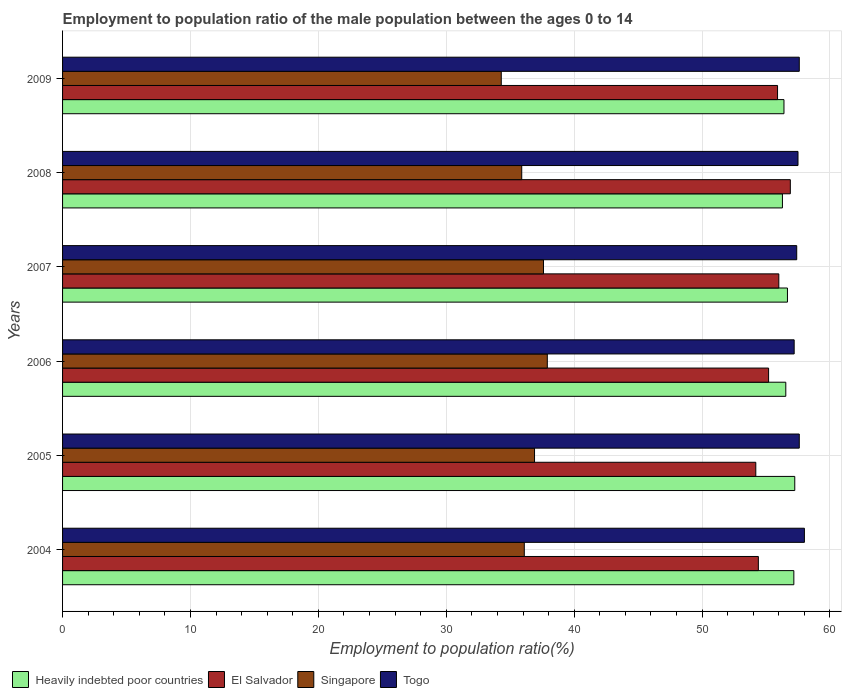How many different coloured bars are there?
Offer a terse response. 4. How many groups of bars are there?
Ensure brevity in your answer.  6. Are the number of bars per tick equal to the number of legend labels?
Ensure brevity in your answer.  Yes. How many bars are there on the 5th tick from the top?
Give a very brief answer. 4. What is the label of the 4th group of bars from the top?
Provide a short and direct response. 2006. In how many cases, is the number of bars for a given year not equal to the number of legend labels?
Provide a succinct answer. 0. What is the employment to population ratio in Heavily indebted poor countries in 2004?
Offer a very short reply. 57.17. Across all years, what is the maximum employment to population ratio in Singapore?
Ensure brevity in your answer.  37.9. Across all years, what is the minimum employment to population ratio in Togo?
Make the answer very short. 57.2. In which year was the employment to population ratio in Heavily indebted poor countries minimum?
Make the answer very short. 2008. What is the total employment to population ratio in Singapore in the graph?
Your answer should be compact. 218.7. What is the difference between the employment to population ratio in Singapore in 2005 and that in 2006?
Keep it short and to the point. -1. What is the difference between the employment to population ratio in Singapore in 2004 and the employment to population ratio in Heavily indebted poor countries in 2005?
Your response must be concise. -21.15. What is the average employment to population ratio in Singapore per year?
Your response must be concise. 36.45. In the year 2006, what is the difference between the employment to population ratio in Singapore and employment to population ratio in El Salvador?
Your answer should be compact. -17.3. In how many years, is the employment to population ratio in Heavily indebted poor countries greater than 56 %?
Give a very brief answer. 6. What is the ratio of the employment to population ratio in El Salvador in 2004 to that in 2007?
Provide a succinct answer. 0.97. Is the employment to population ratio in Singapore in 2005 less than that in 2007?
Offer a terse response. Yes. Is the difference between the employment to population ratio in Singapore in 2004 and 2005 greater than the difference between the employment to population ratio in El Salvador in 2004 and 2005?
Your response must be concise. No. What is the difference between the highest and the second highest employment to population ratio in El Salvador?
Offer a very short reply. 0.9. What is the difference between the highest and the lowest employment to population ratio in Heavily indebted poor countries?
Make the answer very short. 0.96. In how many years, is the employment to population ratio in Heavily indebted poor countries greater than the average employment to population ratio in Heavily indebted poor countries taken over all years?
Provide a short and direct response. 2. Is the sum of the employment to population ratio in Singapore in 2004 and 2007 greater than the maximum employment to population ratio in Heavily indebted poor countries across all years?
Your answer should be very brief. Yes. Is it the case that in every year, the sum of the employment to population ratio in El Salvador and employment to population ratio in Heavily indebted poor countries is greater than the sum of employment to population ratio in Singapore and employment to population ratio in Togo?
Ensure brevity in your answer.  Yes. What does the 2nd bar from the top in 2008 represents?
Ensure brevity in your answer.  Singapore. What does the 4th bar from the bottom in 2005 represents?
Provide a succinct answer. Togo. Is it the case that in every year, the sum of the employment to population ratio in Heavily indebted poor countries and employment to population ratio in Singapore is greater than the employment to population ratio in Togo?
Give a very brief answer. Yes. Are all the bars in the graph horizontal?
Ensure brevity in your answer.  Yes. Are the values on the major ticks of X-axis written in scientific E-notation?
Keep it short and to the point. No. Does the graph contain any zero values?
Make the answer very short. No. How are the legend labels stacked?
Your answer should be compact. Horizontal. What is the title of the graph?
Your answer should be very brief. Employment to population ratio of the male population between the ages 0 to 14. What is the label or title of the X-axis?
Ensure brevity in your answer.  Employment to population ratio(%). What is the Employment to population ratio(%) in Heavily indebted poor countries in 2004?
Keep it short and to the point. 57.17. What is the Employment to population ratio(%) of El Salvador in 2004?
Your answer should be very brief. 54.4. What is the Employment to population ratio(%) of Singapore in 2004?
Provide a short and direct response. 36.1. What is the Employment to population ratio(%) of Togo in 2004?
Offer a very short reply. 58. What is the Employment to population ratio(%) of Heavily indebted poor countries in 2005?
Provide a succinct answer. 57.25. What is the Employment to population ratio(%) of El Salvador in 2005?
Your answer should be very brief. 54.2. What is the Employment to population ratio(%) in Singapore in 2005?
Make the answer very short. 36.9. What is the Employment to population ratio(%) of Togo in 2005?
Keep it short and to the point. 57.6. What is the Employment to population ratio(%) of Heavily indebted poor countries in 2006?
Keep it short and to the point. 56.55. What is the Employment to population ratio(%) in El Salvador in 2006?
Make the answer very short. 55.2. What is the Employment to population ratio(%) of Singapore in 2006?
Give a very brief answer. 37.9. What is the Employment to population ratio(%) in Togo in 2006?
Keep it short and to the point. 57.2. What is the Employment to population ratio(%) of Heavily indebted poor countries in 2007?
Your response must be concise. 56.68. What is the Employment to population ratio(%) in Singapore in 2007?
Give a very brief answer. 37.6. What is the Employment to population ratio(%) in Togo in 2007?
Offer a terse response. 57.4. What is the Employment to population ratio(%) of Heavily indebted poor countries in 2008?
Your response must be concise. 56.28. What is the Employment to population ratio(%) in El Salvador in 2008?
Give a very brief answer. 56.9. What is the Employment to population ratio(%) in Singapore in 2008?
Offer a very short reply. 35.9. What is the Employment to population ratio(%) of Togo in 2008?
Ensure brevity in your answer.  57.5. What is the Employment to population ratio(%) in Heavily indebted poor countries in 2009?
Provide a short and direct response. 56.4. What is the Employment to population ratio(%) in El Salvador in 2009?
Offer a very short reply. 55.9. What is the Employment to population ratio(%) in Singapore in 2009?
Provide a succinct answer. 34.3. What is the Employment to population ratio(%) in Togo in 2009?
Provide a short and direct response. 57.6. Across all years, what is the maximum Employment to population ratio(%) in Heavily indebted poor countries?
Provide a succinct answer. 57.25. Across all years, what is the maximum Employment to population ratio(%) of El Salvador?
Provide a short and direct response. 56.9. Across all years, what is the maximum Employment to population ratio(%) in Singapore?
Give a very brief answer. 37.9. Across all years, what is the maximum Employment to population ratio(%) of Togo?
Give a very brief answer. 58. Across all years, what is the minimum Employment to population ratio(%) of Heavily indebted poor countries?
Ensure brevity in your answer.  56.28. Across all years, what is the minimum Employment to population ratio(%) of El Salvador?
Ensure brevity in your answer.  54.2. Across all years, what is the minimum Employment to population ratio(%) of Singapore?
Keep it short and to the point. 34.3. Across all years, what is the minimum Employment to population ratio(%) of Togo?
Your answer should be very brief. 57.2. What is the total Employment to population ratio(%) in Heavily indebted poor countries in the graph?
Make the answer very short. 340.33. What is the total Employment to population ratio(%) in El Salvador in the graph?
Offer a very short reply. 332.6. What is the total Employment to population ratio(%) of Singapore in the graph?
Offer a terse response. 218.7. What is the total Employment to population ratio(%) in Togo in the graph?
Ensure brevity in your answer.  345.3. What is the difference between the Employment to population ratio(%) of Heavily indebted poor countries in 2004 and that in 2005?
Provide a short and direct response. -0.07. What is the difference between the Employment to population ratio(%) in El Salvador in 2004 and that in 2005?
Offer a very short reply. 0.2. What is the difference between the Employment to population ratio(%) in Singapore in 2004 and that in 2005?
Ensure brevity in your answer.  -0.8. What is the difference between the Employment to population ratio(%) in Heavily indebted poor countries in 2004 and that in 2006?
Ensure brevity in your answer.  0.63. What is the difference between the Employment to population ratio(%) in El Salvador in 2004 and that in 2006?
Give a very brief answer. -0.8. What is the difference between the Employment to population ratio(%) of Togo in 2004 and that in 2006?
Your answer should be compact. 0.8. What is the difference between the Employment to population ratio(%) of Heavily indebted poor countries in 2004 and that in 2007?
Ensure brevity in your answer.  0.5. What is the difference between the Employment to population ratio(%) in El Salvador in 2004 and that in 2007?
Give a very brief answer. -1.6. What is the difference between the Employment to population ratio(%) of Togo in 2004 and that in 2007?
Keep it short and to the point. 0.6. What is the difference between the Employment to population ratio(%) of Heavily indebted poor countries in 2004 and that in 2008?
Provide a succinct answer. 0.89. What is the difference between the Employment to population ratio(%) of El Salvador in 2004 and that in 2008?
Your response must be concise. -2.5. What is the difference between the Employment to population ratio(%) of Singapore in 2004 and that in 2008?
Keep it short and to the point. 0.2. What is the difference between the Employment to population ratio(%) in Heavily indebted poor countries in 2004 and that in 2009?
Provide a succinct answer. 0.77. What is the difference between the Employment to population ratio(%) of El Salvador in 2004 and that in 2009?
Make the answer very short. -1.5. What is the difference between the Employment to population ratio(%) in Singapore in 2004 and that in 2009?
Offer a very short reply. 1.8. What is the difference between the Employment to population ratio(%) of Togo in 2004 and that in 2009?
Your answer should be very brief. 0.4. What is the difference between the Employment to population ratio(%) in Heavily indebted poor countries in 2005 and that in 2006?
Ensure brevity in your answer.  0.7. What is the difference between the Employment to population ratio(%) in El Salvador in 2005 and that in 2006?
Provide a short and direct response. -1. What is the difference between the Employment to population ratio(%) of Singapore in 2005 and that in 2006?
Offer a very short reply. -1. What is the difference between the Employment to population ratio(%) in Heavily indebted poor countries in 2005 and that in 2007?
Offer a very short reply. 0.57. What is the difference between the Employment to population ratio(%) in Singapore in 2005 and that in 2007?
Provide a succinct answer. -0.7. What is the difference between the Employment to population ratio(%) in Heavily indebted poor countries in 2005 and that in 2008?
Your answer should be very brief. 0.96. What is the difference between the Employment to population ratio(%) in El Salvador in 2005 and that in 2008?
Ensure brevity in your answer.  -2.7. What is the difference between the Employment to population ratio(%) in Singapore in 2005 and that in 2008?
Your response must be concise. 1. What is the difference between the Employment to population ratio(%) in Togo in 2005 and that in 2008?
Offer a very short reply. 0.1. What is the difference between the Employment to population ratio(%) of Heavily indebted poor countries in 2005 and that in 2009?
Your answer should be very brief. 0.84. What is the difference between the Employment to population ratio(%) in Togo in 2005 and that in 2009?
Your response must be concise. 0. What is the difference between the Employment to population ratio(%) in Heavily indebted poor countries in 2006 and that in 2007?
Offer a terse response. -0.13. What is the difference between the Employment to population ratio(%) in El Salvador in 2006 and that in 2007?
Ensure brevity in your answer.  -0.8. What is the difference between the Employment to population ratio(%) in Singapore in 2006 and that in 2007?
Give a very brief answer. 0.3. What is the difference between the Employment to population ratio(%) of Togo in 2006 and that in 2007?
Offer a terse response. -0.2. What is the difference between the Employment to population ratio(%) of Heavily indebted poor countries in 2006 and that in 2008?
Keep it short and to the point. 0.26. What is the difference between the Employment to population ratio(%) in El Salvador in 2006 and that in 2008?
Keep it short and to the point. -1.7. What is the difference between the Employment to population ratio(%) of Togo in 2006 and that in 2008?
Provide a short and direct response. -0.3. What is the difference between the Employment to population ratio(%) in Heavily indebted poor countries in 2006 and that in 2009?
Provide a succinct answer. 0.14. What is the difference between the Employment to population ratio(%) in Heavily indebted poor countries in 2007 and that in 2008?
Give a very brief answer. 0.39. What is the difference between the Employment to population ratio(%) of El Salvador in 2007 and that in 2008?
Provide a succinct answer. -0.9. What is the difference between the Employment to population ratio(%) of Singapore in 2007 and that in 2008?
Give a very brief answer. 1.7. What is the difference between the Employment to population ratio(%) of Heavily indebted poor countries in 2007 and that in 2009?
Your response must be concise. 0.27. What is the difference between the Employment to population ratio(%) of Togo in 2007 and that in 2009?
Your answer should be very brief. -0.2. What is the difference between the Employment to population ratio(%) of Heavily indebted poor countries in 2008 and that in 2009?
Ensure brevity in your answer.  -0.12. What is the difference between the Employment to population ratio(%) of Singapore in 2008 and that in 2009?
Your answer should be compact. 1.6. What is the difference between the Employment to population ratio(%) in Togo in 2008 and that in 2009?
Ensure brevity in your answer.  -0.1. What is the difference between the Employment to population ratio(%) in Heavily indebted poor countries in 2004 and the Employment to population ratio(%) in El Salvador in 2005?
Offer a terse response. 2.97. What is the difference between the Employment to population ratio(%) in Heavily indebted poor countries in 2004 and the Employment to population ratio(%) in Singapore in 2005?
Your answer should be compact. 20.27. What is the difference between the Employment to population ratio(%) of Heavily indebted poor countries in 2004 and the Employment to population ratio(%) of Togo in 2005?
Ensure brevity in your answer.  -0.43. What is the difference between the Employment to population ratio(%) in Singapore in 2004 and the Employment to population ratio(%) in Togo in 2005?
Your answer should be very brief. -21.5. What is the difference between the Employment to population ratio(%) in Heavily indebted poor countries in 2004 and the Employment to population ratio(%) in El Salvador in 2006?
Make the answer very short. 1.97. What is the difference between the Employment to population ratio(%) in Heavily indebted poor countries in 2004 and the Employment to population ratio(%) in Singapore in 2006?
Give a very brief answer. 19.27. What is the difference between the Employment to population ratio(%) in Heavily indebted poor countries in 2004 and the Employment to population ratio(%) in Togo in 2006?
Give a very brief answer. -0.03. What is the difference between the Employment to population ratio(%) in El Salvador in 2004 and the Employment to population ratio(%) in Singapore in 2006?
Your answer should be very brief. 16.5. What is the difference between the Employment to population ratio(%) in El Salvador in 2004 and the Employment to population ratio(%) in Togo in 2006?
Ensure brevity in your answer.  -2.8. What is the difference between the Employment to population ratio(%) of Singapore in 2004 and the Employment to population ratio(%) of Togo in 2006?
Your answer should be very brief. -21.1. What is the difference between the Employment to population ratio(%) of Heavily indebted poor countries in 2004 and the Employment to population ratio(%) of El Salvador in 2007?
Provide a short and direct response. 1.17. What is the difference between the Employment to population ratio(%) of Heavily indebted poor countries in 2004 and the Employment to population ratio(%) of Singapore in 2007?
Make the answer very short. 19.57. What is the difference between the Employment to population ratio(%) in Heavily indebted poor countries in 2004 and the Employment to population ratio(%) in Togo in 2007?
Your answer should be very brief. -0.23. What is the difference between the Employment to population ratio(%) of El Salvador in 2004 and the Employment to population ratio(%) of Togo in 2007?
Your answer should be compact. -3. What is the difference between the Employment to population ratio(%) of Singapore in 2004 and the Employment to population ratio(%) of Togo in 2007?
Offer a terse response. -21.3. What is the difference between the Employment to population ratio(%) in Heavily indebted poor countries in 2004 and the Employment to population ratio(%) in El Salvador in 2008?
Make the answer very short. 0.27. What is the difference between the Employment to population ratio(%) of Heavily indebted poor countries in 2004 and the Employment to population ratio(%) of Singapore in 2008?
Your answer should be very brief. 21.27. What is the difference between the Employment to population ratio(%) of Heavily indebted poor countries in 2004 and the Employment to population ratio(%) of Togo in 2008?
Offer a very short reply. -0.33. What is the difference between the Employment to population ratio(%) of El Salvador in 2004 and the Employment to population ratio(%) of Togo in 2008?
Give a very brief answer. -3.1. What is the difference between the Employment to population ratio(%) in Singapore in 2004 and the Employment to population ratio(%) in Togo in 2008?
Offer a very short reply. -21.4. What is the difference between the Employment to population ratio(%) of Heavily indebted poor countries in 2004 and the Employment to population ratio(%) of El Salvador in 2009?
Your answer should be compact. 1.27. What is the difference between the Employment to population ratio(%) of Heavily indebted poor countries in 2004 and the Employment to population ratio(%) of Singapore in 2009?
Provide a succinct answer. 22.87. What is the difference between the Employment to population ratio(%) of Heavily indebted poor countries in 2004 and the Employment to population ratio(%) of Togo in 2009?
Your answer should be very brief. -0.43. What is the difference between the Employment to population ratio(%) of El Salvador in 2004 and the Employment to population ratio(%) of Singapore in 2009?
Offer a terse response. 20.1. What is the difference between the Employment to population ratio(%) in El Salvador in 2004 and the Employment to population ratio(%) in Togo in 2009?
Make the answer very short. -3.2. What is the difference between the Employment to population ratio(%) of Singapore in 2004 and the Employment to population ratio(%) of Togo in 2009?
Keep it short and to the point. -21.5. What is the difference between the Employment to population ratio(%) in Heavily indebted poor countries in 2005 and the Employment to population ratio(%) in El Salvador in 2006?
Your response must be concise. 2.05. What is the difference between the Employment to population ratio(%) of Heavily indebted poor countries in 2005 and the Employment to population ratio(%) of Singapore in 2006?
Ensure brevity in your answer.  19.35. What is the difference between the Employment to population ratio(%) in Heavily indebted poor countries in 2005 and the Employment to population ratio(%) in Togo in 2006?
Your answer should be very brief. 0.05. What is the difference between the Employment to population ratio(%) in El Salvador in 2005 and the Employment to population ratio(%) in Togo in 2006?
Offer a very short reply. -3. What is the difference between the Employment to population ratio(%) in Singapore in 2005 and the Employment to population ratio(%) in Togo in 2006?
Your answer should be very brief. -20.3. What is the difference between the Employment to population ratio(%) in Heavily indebted poor countries in 2005 and the Employment to population ratio(%) in El Salvador in 2007?
Offer a very short reply. 1.25. What is the difference between the Employment to population ratio(%) of Heavily indebted poor countries in 2005 and the Employment to population ratio(%) of Singapore in 2007?
Make the answer very short. 19.65. What is the difference between the Employment to population ratio(%) of Heavily indebted poor countries in 2005 and the Employment to population ratio(%) of Togo in 2007?
Provide a succinct answer. -0.15. What is the difference between the Employment to population ratio(%) of Singapore in 2005 and the Employment to population ratio(%) of Togo in 2007?
Your answer should be very brief. -20.5. What is the difference between the Employment to population ratio(%) in Heavily indebted poor countries in 2005 and the Employment to population ratio(%) in El Salvador in 2008?
Your answer should be very brief. 0.35. What is the difference between the Employment to population ratio(%) in Heavily indebted poor countries in 2005 and the Employment to population ratio(%) in Singapore in 2008?
Make the answer very short. 21.35. What is the difference between the Employment to population ratio(%) in Heavily indebted poor countries in 2005 and the Employment to population ratio(%) in Togo in 2008?
Offer a terse response. -0.25. What is the difference between the Employment to population ratio(%) in El Salvador in 2005 and the Employment to population ratio(%) in Togo in 2008?
Provide a succinct answer. -3.3. What is the difference between the Employment to population ratio(%) of Singapore in 2005 and the Employment to population ratio(%) of Togo in 2008?
Make the answer very short. -20.6. What is the difference between the Employment to population ratio(%) of Heavily indebted poor countries in 2005 and the Employment to population ratio(%) of El Salvador in 2009?
Give a very brief answer. 1.35. What is the difference between the Employment to population ratio(%) of Heavily indebted poor countries in 2005 and the Employment to population ratio(%) of Singapore in 2009?
Keep it short and to the point. 22.95. What is the difference between the Employment to population ratio(%) of Heavily indebted poor countries in 2005 and the Employment to population ratio(%) of Togo in 2009?
Make the answer very short. -0.35. What is the difference between the Employment to population ratio(%) of El Salvador in 2005 and the Employment to population ratio(%) of Singapore in 2009?
Offer a terse response. 19.9. What is the difference between the Employment to population ratio(%) of El Salvador in 2005 and the Employment to population ratio(%) of Togo in 2009?
Make the answer very short. -3.4. What is the difference between the Employment to population ratio(%) in Singapore in 2005 and the Employment to population ratio(%) in Togo in 2009?
Give a very brief answer. -20.7. What is the difference between the Employment to population ratio(%) in Heavily indebted poor countries in 2006 and the Employment to population ratio(%) in El Salvador in 2007?
Ensure brevity in your answer.  0.55. What is the difference between the Employment to population ratio(%) in Heavily indebted poor countries in 2006 and the Employment to population ratio(%) in Singapore in 2007?
Provide a short and direct response. 18.95. What is the difference between the Employment to population ratio(%) of Heavily indebted poor countries in 2006 and the Employment to population ratio(%) of Togo in 2007?
Your answer should be compact. -0.85. What is the difference between the Employment to population ratio(%) in El Salvador in 2006 and the Employment to population ratio(%) in Singapore in 2007?
Ensure brevity in your answer.  17.6. What is the difference between the Employment to population ratio(%) of Singapore in 2006 and the Employment to population ratio(%) of Togo in 2007?
Your answer should be very brief. -19.5. What is the difference between the Employment to population ratio(%) of Heavily indebted poor countries in 2006 and the Employment to population ratio(%) of El Salvador in 2008?
Ensure brevity in your answer.  -0.35. What is the difference between the Employment to population ratio(%) in Heavily indebted poor countries in 2006 and the Employment to population ratio(%) in Singapore in 2008?
Your answer should be very brief. 20.65. What is the difference between the Employment to population ratio(%) in Heavily indebted poor countries in 2006 and the Employment to population ratio(%) in Togo in 2008?
Your answer should be compact. -0.95. What is the difference between the Employment to population ratio(%) in El Salvador in 2006 and the Employment to population ratio(%) in Singapore in 2008?
Keep it short and to the point. 19.3. What is the difference between the Employment to population ratio(%) in El Salvador in 2006 and the Employment to population ratio(%) in Togo in 2008?
Your answer should be compact. -2.3. What is the difference between the Employment to population ratio(%) in Singapore in 2006 and the Employment to population ratio(%) in Togo in 2008?
Offer a very short reply. -19.6. What is the difference between the Employment to population ratio(%) of Heavily indebted poor countries in 2006 and the Employment to population ratio(%) of El Salvador in 2009?
Your response must be concise. 0.65. What is the difference between the Employment to population ratio(%) in Heavily indebted poor countries in 2006 and the Employment to population ratio(%) in Singapore in 2009?
Give a very brief answer. 22.25. What is the difference between the Employment to population ratio(%) in Heavily indebted poor countries in 2006 and the Employment to population ratio(%) in Togo in 2009?
Make the answer very short. -1.05. What is the difference between the Employment to population ratio(%) in El Salvador in 2006 and the Employment to population ratio(%) in Singapore in 2009?
Offer a very short reply. 20.9. What is the difference between the Employment to population ratio(%) in El Salvador in 2006 and the Employment to population ratio(%) in Togo in 2009?
Offer a terse response. -2.4. What is the difference between the Employment to population ratio(%) in Singapore in 2006 and the Employment to population ratio(%) in Togo in 2009?
Ensure brevity in your answer.  -19.7. What is the difference between the Employment to population ratio(%) of Heavily indebted poor countries in 2007 and the Employment to population ratio(%) of El Salvador in 2008?
Provide a succinct answer. -0.22. What is the difference between the Employment to population ratio(%) of Heavily indebted poor countries in 2007 and the Employment to population ratio(%) of Singapore in 2008?
Give a very brief answer. 20.78. What is the difference between the Employment to population ratio(%) in Heavily indebted poor countries in 2007 and the Employment to population ratio(%) in Togo in 2008?
Your answer should be compact. -0.82. What is the difference between the Employment to population ratio(%) of El Salvador in 2007 and the Employment to population ratio(%) of Singapore in 2008?
Offer a terse response. 20.1. What is the difference between the Employment to population ratio(%) of Singapore in 2007 and the Employment to population ratio(%) of Togo in 2008?
Offer a terse response. -19.9. What is the difference between the Employment to population ratio(%) of Heavily indebted poor countries in 2007 and the Employment to population ratio(%) of El Salvador in 2009?
Provide a succinct answer. 0.78. What is the difference between the Employment to population ratio(%) in Heavily indebted poor countries in 2007 and the Employment to population ratio(%) in Singapore in 2009?
Provide a short and direct response. 22.38. What is the difference between the Employment to population ratio(%) of Heavily indebted poor countries in 2007 and the Employment to population ratio(%) of Togo in 2009?
Your answer should be very brief. -0.92. What is the difference between the Employment to population ratio(%) in El Salvador in 2007 and the Employment to population ratio(%) in Singapore in 2009?
Your response must be concise. 21.7. What is the difference between the Employment to population ratio(%) of El Salvador in 2007 and the Employment to population ratio(%) of Togo in 2009?
Make the answer very short. -1.6. What is the difference between the Employment to population ratio(%) in Heavily indebted poor countries in 2008 and the Employment to population ratio(%) in El Salvador in 2009?
Provide a short and direct response. 0.38. What is the difference between the Employment to population ratio(%) in Heavily indebted poor countries in 2008 and the Employment to population ratio(%) in Singapore in 2009?
Provide a succinct answer. 21.98. What is the difference between the Employment to population ratio(%) of Heavily indebted poor countries in 2008 and the Employment to population ratio(%) of Togo in 2009?
Offer a terse response. -1.32. What is the difference between the Employment to population ratio(%) of El Salvador in 2008 and the Employment to population ratio(%) of Singapore in 2009?
Make the answer very short. 22.6. What is the difference between the Employment to population ratio(%) in Singapore in 2008 and the Employment to population ratio(%) in Togo in 2009?
Your answer should be very brief. -21.7. What is the average Employment to population ratio(%) in Heavily indebted poor countries per year?
Your answer should be very brief. 56.72. What is the average Employment to population ratio(%) in El Salvador per year?
Your answer should be very brief. 55.43. What is the average Employment to population ratio(%) in Singapore per year?
Your answer should be very brief. 36.45. What is the average Employment to population ratio(%) in Togo per year?
Offer a very short reply. 57.55. In the year 2004, what is the difference between the Employment to population ratio(%) in Heavily indebted poor countries and Employment to population ratio(%) in El Salvador?
Provide a short and direct response. 2.77. In the year 2004, what is the difference between the Employment to population ratio(%) of Heavily indebted poor countries and Employment to population ratio(%) of Singapore?
Offer a terse response. 21.07. In the year 2004, what is the difference between the Employment to population ratio(%) in Heavily indebted poor countries and Employment to population ratio(%) in Togo?
Ensure brevity in your answer.  -0.83. In the year 2004, what is the difference between the Employment to population ratio(%) of Singapore and Employment to population ratio(%) of Togo?
Give a very brief answer. -21.9. In the year 2005, what is the difference between the Employment to population ratio(%) in Heavily indebted poor countries and Employment to population ratio(%) in El Salvador?
Your answer should be very brief. 3.05. In the year 2005, what is the difference between the Employment to population ratio(%) in Heavily indebted poor countries and Employment to population ratio(%) in Singapore?
Your answer should be compact. 20.35. In the year 2005, what is the difference between the Employment to population ratio(%) in Heavily indebted poor countries and Employment to population ratio(%) in Togo?
Your response must be concise. -0.35. In the year 2005, what is the difference between the Employment to population ratio(%) of El Salvador and Employment to population ratio(%) of Singapore?
Ensure brevity in your answer.  17.3. In the year 2005, what is the difference between the Employment to population ratio(%) in El Salvador and Employment to population ratio(%) in Togo?
Provide a short and direct response. -3.4. In the year 2005, what is the difference between the Employment to population ratio(%) of Singapore and Employment to population ratio(%) of Togo?
Ensure brevity in your answer.  -20.7. In the year 2006, what is the difference between the Employment to population ratio(%) of Heavily indebted poor countries and Employment to population ratio(%) of El Salvador?
Ensure brevity in your answer.  1.35. In the year 2006, what is the difference between the Employment to population ratio(%) in Heavily indebted poor countries and Employment to population ratio(%) in Singapore?
Make the answer very short. 18.65. In the year 2006, what is the difference between the Employment to population ratio(%) of Heavily indebted poor countries and Employment to population ratio(%) of Togo?
Keep it short and to the point. -0.65. In the year 2006, what is the difference between the Employment to population ratio(%) of El Salvador and Employment to population ratio(%) of Singapore?
Give a very brief answer. 17.3. In the year 2006, what is the difference between the Employment to population ratio(%) of Singapore and Employment to population ratio(%) of Togo?
Your answer should be compact. -19.3. In the year 2007, what is the difference between the Employment to population ratio(%) in Heavily indebted poor countries and Employment to population ratio(%) in El Salvador?
Offer a terse response. 0.68. In the year 2007, what is the difference between the Employment to population ratio(%) in Heavily indebted poor countries and Employment to population ratio(%) in Singapore?
Keep it short and to the point. 19.08. In the year 2007, what is the difference between the Employment to population ratio(%) of Heavily indebted poor countries and Employment to population ratio(%) of Togo?
Offer a terse response. -0.72. In the year 2007, what is the difference between the Employment to population ratio(%) in El Salvador and Employment to population ratio(%) in Togo?
Offer a very short reply. -1.4. In the year 2007, what is the difference between the Employment to population ratio(%) in Singapore and Employment to population ratio(%) in Togo?
Offer a very short reply. -19.8. In the year 2008, what is the difference between the Employment to population ratio(%) in Heavily indebted poor countries and Employment to population ratio(%) in El Salvador?
Provide a succinct answer. -0.62. In the year 2008, what is the difference between the Employment to population ratio(%) in Heavily indebted poor countries and Employment to population ratio(%) in Singapore?
Provide a short and direct response. 20.38. In the year 2008, what is the difference between the Employment to population ratio(%) in Heavily indebted poor countries and Employment to population ratio(%) in Togo?
Keep it short and to the point. -1.22. In the year 2008, what is the difference between the Employment to population ratio(%) of Singapore and Employment to population ratio(%) of Togo?
Make the answer very short. -21.6. In the year 2009, what is the difference between the Employment to population ratio(%) in Heavily indebted poor countries and Employment to population ratio(%) in El Salvador?
Your answer should be compact. 0.5. In the year 2009, what is the difference between the Employment to population ratio(%) in Heavily indebted poor countries and Employment to population ratio(%) in Singapore?
Provide a short and direct response. 22.1. In the year 2009, what is the difference between the Employment to population ratio(%) of Heavily indebted poor countries and Employment to population ratio(%) of Togo?
Keep it short and to the point. -1.2. In the year 2009, what is the difference between the Employment to population ratio(%) of El Salvador and Employment to population ratio(%) of Singapore?
Provide a succinct answer. 21.6. In the year 2009, what is the difference between the Employment to population ratio(%) in Singapore and Employment to population ratio(%) in Togo?
Give a very brief answer. -23.3. What is the ratio of the Employment to population ratio(%) of Heavily indebted poor countries in 2004 to that in 2005?
Your answer should be very brief. 1. What is the ratio of the Employment to population ratio(%) of Singapore in 2004 to that in 2005?
Your answer should be very brief. 0.98. What is the ratio of the Employment to population ratio(%) in Heavily indebted poor countries in 2004 to that in 2006?
Provide a succinct answer. 1.01. What is the ratio of the Employment to population ratio(%) in El Salvador in 2004 to that in 2006?
Your answer should be very brief. 0.99. What is the ratio of the Employment to population ratio(%) in Singapore in 2004 to that in 2006?
Your answer should be compact. 0.95. What is the ratio of the Employment to population ratio(%) in Togo in 2004 to that in 2006?
Keep it short and to the point. 1.01. What is the ratio of the Employment to population ratio(%) of Heavily indebted poor countries in 2004 to that in 2007?
Make the answer very short. 1.01. What is the ratio of the Employment to population ratio(%) of El Salvador in 2004 to that in 2007?
Provide a short and direct response. 0.97. What is the ratio of the Employment to population ratio(%) in Singapore in 2004 to that in 2007?
Give a very brief answer. 0.96. What is the ratio of the Employment to population ratio(%) in Togo in 2004 to that in 2007?
Give a very brief answer. 1.01. What is the ratio of the Employment to population ratio(%) of Heavily indebted poor countries in 2004 to that in 2008?
Offer a very short reply. 1.02. What is the ratio of the Employment to population ratio(%) of El Salvador in 2004 to that in 2008?
Offer a very short reply. 0.96. What is the ratio of the Employment to population ratio(%) in Singapore in 2004 to that in 2008?
Make the answer very short. 1.01. What is the ratio of the Employment to population ratio(%) in Togo in 2004 to that in 2008?
Your answer should be very brief. 1.01. What is the ratio of the Employment to population ratio(%) of Heavily indebted poor countries in 2004 to that in 2009?
Ensure brevity in your answer.  1.01. What is the ratio of the Employment to population ratio(%) in El Salvador in 2004 to that in 2009?
Provide a short and direct response. 0.97. What is the ratio of the Employment to population ratio(%) in Singapore in 2004 to that in 2009?
Your answer should be very brief. 1.05. What is the ratio of the Employment to population ratio(%) of Togo in 2004 to that in 2009?
Your answer should be very brief. 1.01. What is the ratio of the Employment to population ratio(%) of Heavily indebted poor countries in 2005 to that in 2006?
Keep it short and to the point. 1.01. What is the ratio of the Employment to population ratio(%) of El Salvador in 2005 to that in 2006?
Your response must be concise. 0.98. What is the ratio of the Employment to population ratio(%) in Singapore in 2005 to that in 2006?
Offer a very short reply. 0.97. What is the ratio of the Employment to population ratio(%) of Togo in 2005 to that in 2006?
Your response must be concise. 1.01. What is the ratio of the Employment to population ratio(%) in Heavily indebted poor countries in 2005 to that in 2007?
Your answer should be very brief. 1.01. What is the ratio of the Employment to population ratio(%) in El Salvador in 2005 to that in 2007?
Offer a very short reply. 0.97. What is the ratio of the Employment to population ratio(%) in Singapore in 2005 to that in 2007?
Offer a terse response. 0.98. What is the ratio of the Employment to population ratio(%) of Heavily indebted poor countries in 2005 to that in 2008?
Offer a very short reply. 1.02. What is the ratio of the Employment to population ratio(%) in El Salvador in 2005 to that in 2008?
Your answer should be very brief. 0.95. What is the ratio of the Employment to population ratio(%) in Singapore in 2005 to that in 2008?
Give a very brief answer. 1.03. What is the ratio of the Employment to population ratio(%) of Heavily indebted poor countries in 2005 to that in 2009?
Ensure brevity in your answer.  1.01. What is the ratio of the Employment to population ratio(%) of El Salvador in 2005 to that in 2009?
Give a very brief answer. 0.97. What is the ratio of the Employment to population ratio(%) of Singapore in 2005 to that in 2009?
Give a very brief answer. 1.08. What is the ratio of the Employment to population ratio(%) of Togo in 2005 to that in 2009?
Keep it short and to the point. 1. What is the ratio of the Employment to population ratio(%) of El Salvador in 2006 to that in 2007?
Offer a terse response. 0.99. What is the ratio of the Employment to population ratio(%) of Singapore in 2006 to that in 2007?
Your answer should be compact. 1.01. What is the ratio of the Employment to population ratio(%) of Togo in 2006 to that in 2007?
Keep it short and to the point. 1. What is the ratio of the Employment to population ratio(%) in Heavily indebted poor countries in 2006 to that in 2008?
Make the answer very short. 1. What is the ratio of the Employment to population ratio(%) of El Salvador in 2006 to that in 2008?
Make the answer very short. 0.97. What is the ratio of the Employment to population ratio(%) in Singapore in 2006 to that in 2008?
Give a very brief answer. 1.06. What is the ratio of the Employment to population ratio(%) of Togo in 2006 to that in 2008?
Your answer should be very brief. 0.99. What is the ratio of the Employment to population ratio(%) in Heavily indebted poor countries in 2006 to that in 2009?
Offer a very short reply. 1. What is the ratio of the Employment to population ratio(%) in El Salvador in 2006 to that in 2009?
Your response must be concise. 0.99. What is the ratio of the Employment to population ratio(%) of Singapore in 2006 to that in 2009?
Your answer should be very brief. 1.1. What is the ratio of the Employment to population ratio(%) of Togo in 2006 to that in 2009?
Give a very brief answer. 0.99. What is the ratio of the Employment to population ratio(%) in Heavily indebted poor countries in 2007 to that in 2008?
Your answer should be very brief. 1.01. What is the ratio of the Employment to population ratio(%) of El Salvador in 2007 to that in 2008?
Provide a succinct answer. 0.98. What is the ratio of the Employment to population ratio(%) in Singapore in 2007 to that in 2008?
Offer a terse response. 1.05. What is the ratio of the Employment to population ratio(%) of Singapore in 2007 to that in 2009?
Give a very brief answer. 1.1. What is the ratio of the Employment to population ratio(%) in Heavily indebted poor countries in 2008 to that in 2009?
Make the answer very short. 1. What is the ratio of the Employment to population ratio(%) of El Salvador in 2008 to that in 2009?
Provide a short and direct response. 1.02. What is the ratio of the Employment to population ratio(%) of Singapore in 2008 to that in 2009?
Provide a short and direct response. 1.05. What is the difference between the highest and the second highest Employment to population ratio(%) in Heavily indebted poor countries?
Your answer should be very brief. 0.07. What is the difference between the highest and the lowest Employment to population ratio(%) in Heavily indebted poor countries?
Provide a short and direct response. 0.96. What is the difference between the highest and the lowest Employment to population ratio(%) of Togo?
Provide a succinct answer. 0.8. 